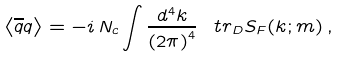Convert formula to latex. <formula><loc_0><loc_0><loc_500><loc_500>\left < { \overline { q } } q \right > = - i \, N _ { c } \int \frac { d ^ { 4 } k } { \left ( 2 \pi \right ) ^ { 4 } } \, \ t r _ { D } S _ { F } ( k ; m ) \, ,</formula> 